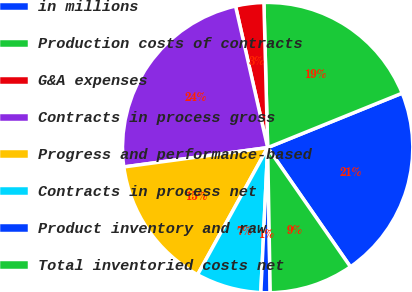<chart> <loc_0><loc_0><loc_500><loc_500><pie_chart><fcel>in millions<fcel>Production costs of contracts<fcel>G&A expenses<fcel>Contracts in process gross<fcel>Progress and performance-based<fcel>Contracts in process net<fcel>Product inventory and raw<fcel>Total inventoried costs net<nl><fcel>21.46%<fcel>19.29%<fcel>3.14%<fcel>23.57%<fcel>14.85%<fcel>7.27%<fcel>1.03%<fcel>9.38%<nl></chart> 